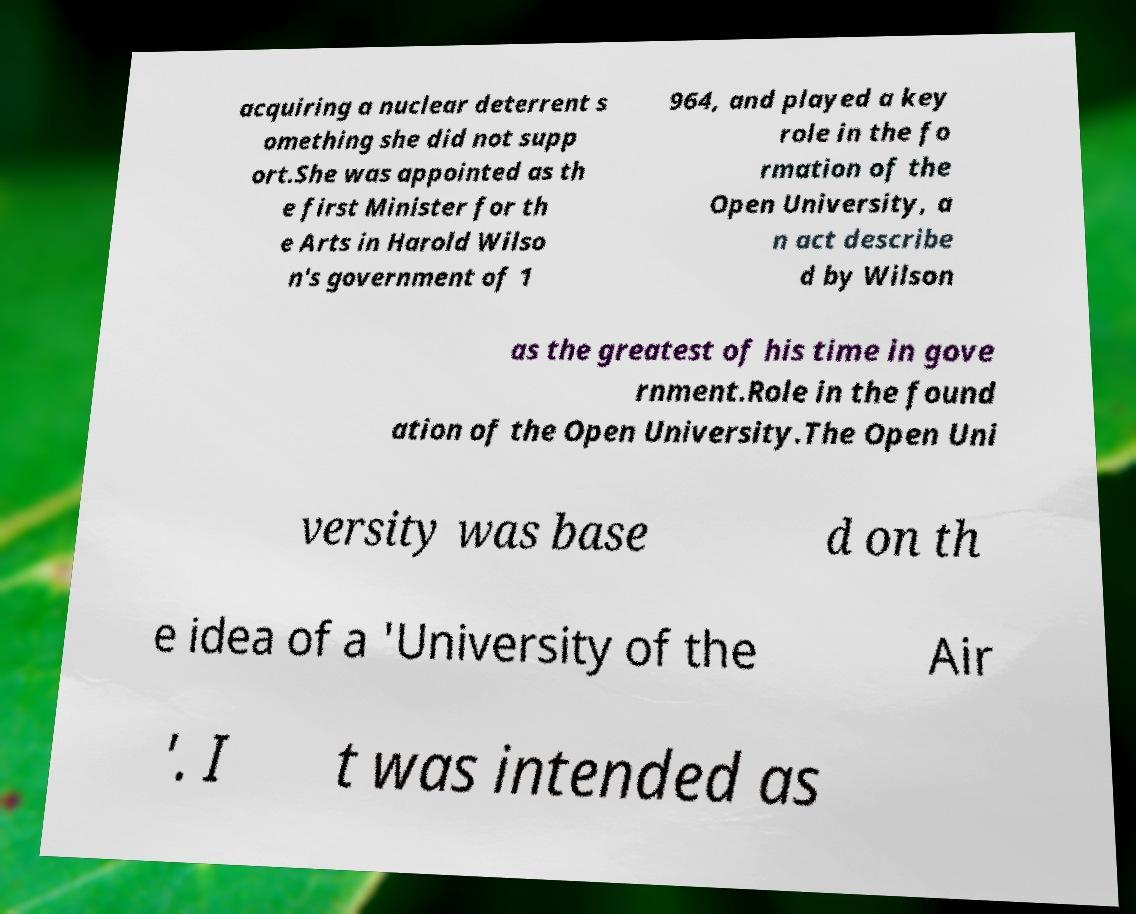What messages or text are displayed in this image? I need them in a readable, typed format. acquiring a nuclear deterrent s omething she did not supp ort.She was appointed as th e first Minister for th e Arts in Harold Wilso n's government of 1 964, and played a key role in the fo rmation of the Open University, a n act describe d by Wilson as the greatest of his time in gove rnment.Role in the found ation of the Open University.The Open Uni versity was base d on th e idea of a 'University of the Air '. I t was intended as 